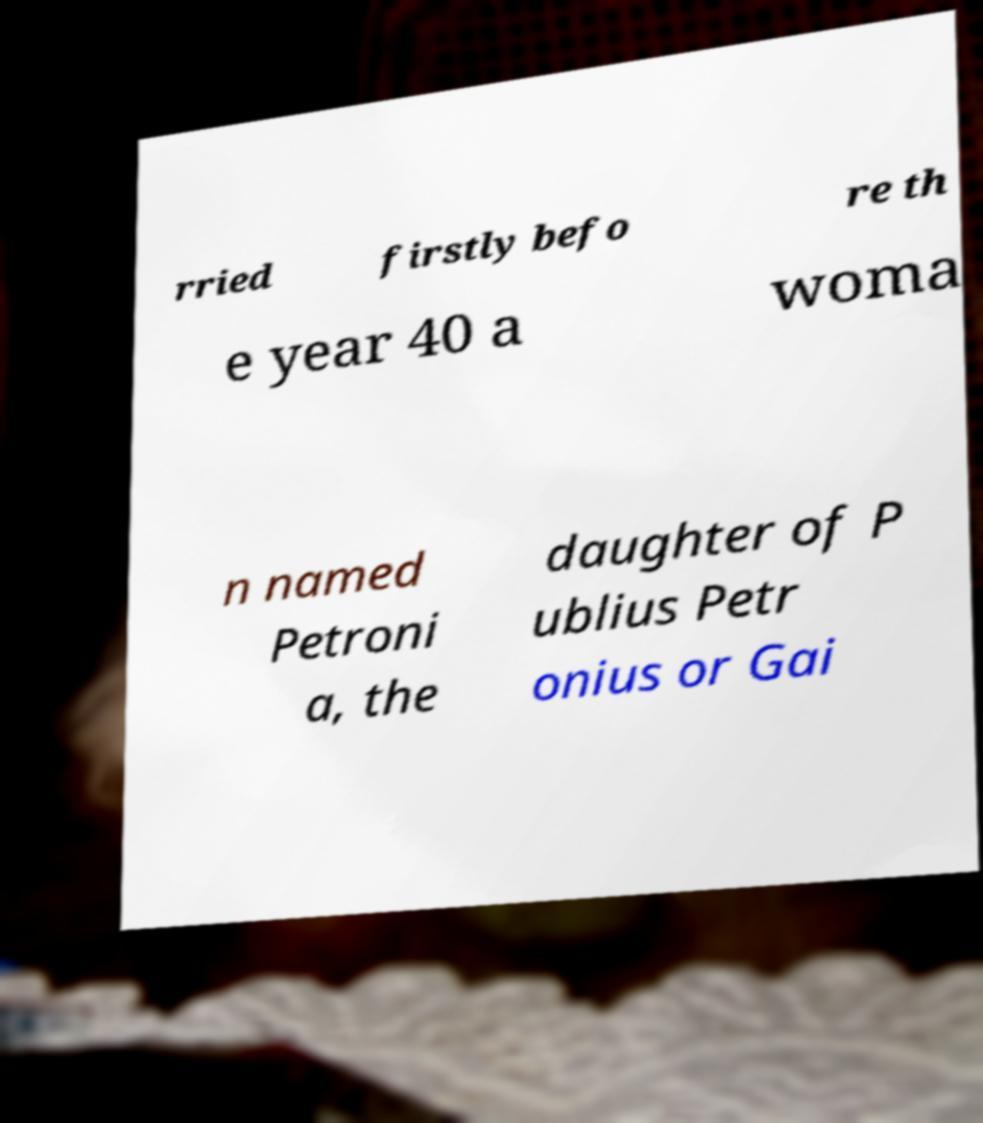For documentation purposes, I need the text within this image transcribed. Could you provide that? rried firstly befo re th e year 40 a woma n named Petroni a, the daughter of P ublius Petr onius or Gai 